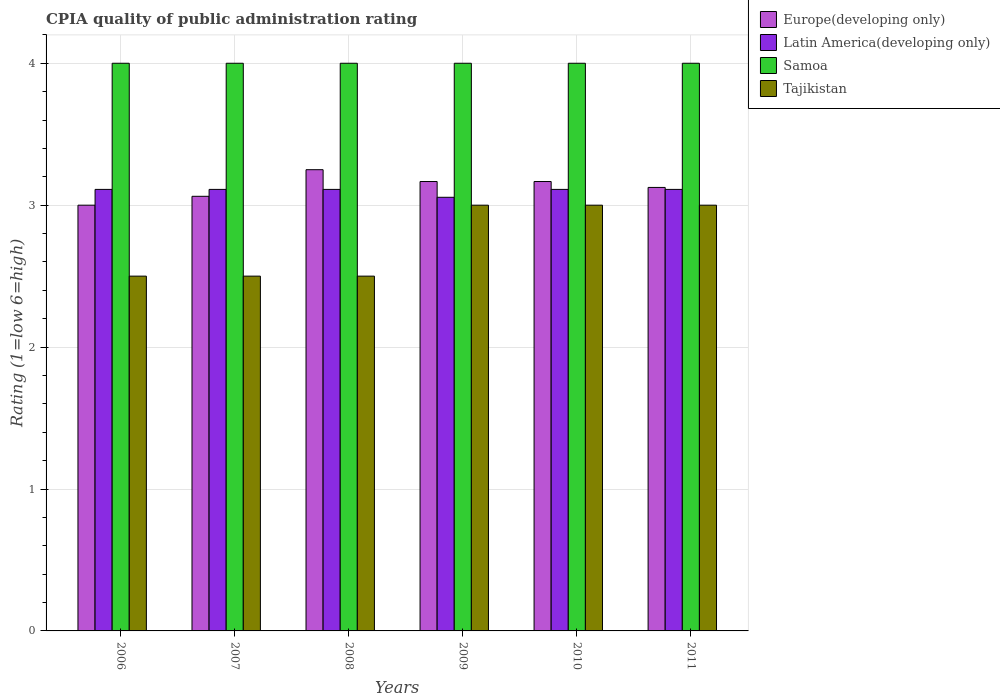How many groups of bars are there?
Make the answer very short. 6. Are the number of bars on each tick of the X-axis equal?
Keep it short and to the point. Yes. How many bars are there on the 2nd tick from the left?
Offer a terse response. 4. How many bars are there on the 4th tick from the right?
Keep it short and to the point. 4. In how many cases, is the number of bars for a given year not equal to the number of legend labels?
Offer a terse response. 0. Across all years, what is the minimum CPIA rating in Latin America(developing only)?
Your answer should be compact. 3.06. In which year was the CPIA rating in Tajikistan maximum?
Your answer should be compact. 2009. What is the difference between the CPIA rating in Europe(developing only) in 2007 and that in 2008?
Offer a terse response. -0.19. What is the difference between the CPIA rating in Tajikistan in 2008 and the CPIA rating in Europe(developing only) in 2010?
Your response must be concise. -0.67. What is the average CPIA rating in Latin America(developing only) per year?
Provide a succinct answer. 3.1. In the year 2007, what is the difference between the CPIA rating in Samoa and CPIA rating in Tajikistan?
Keep it short and to the point. 1.5. In how many years, is the CPIA rating in Samoa greater than 3.2?
Make the answer very short. 6. What is the ratio of the CPIA rating in Europe(developing only) in 2007 to that in 2011?
Your answer should be very brief. 0.98. What is the difference between the highest and the lowest CPIA rating in Latin America(developing only)?
Provide a succinct answer. 0.06. In how many years, is the CPIA rating in Europe(developing only) greater than the average CPIA rating in Europe(developing only) taken over all years?
Offer a terse response. 3. Is the sum of the CPIA rating in Samoa in 2009 and 2011 greater than the maximum CPIA rating in Latin America(developing only) across all years?
Your answer should be very brief. Yes. What does the 1st bar from the left in 2006 represents?
Your answer should be very brief. Europe(developing only). What does the 1st bar from the right in 2008 represents?
Your response must be concise. Tajikistan. Are all the bars in the graph horizontal?
Your response must be concise. No. How many years are there in the graph?
Your response must be concise. 6. Does the graph contain grids?
Provide a succinct answer. Yes. Where does the legend appear in the graph?
Make the answer very short. Top right. How many legend labels are there?
Your answer should be very brief. 4. How are the legend labels stacked?
Your response must be concise. Vertical. What is the title of the graph?
Your answer should be compact. CPIA quality of public administration rating. Does "Algeria" appear as one of the legend labels in the graph?
Keep it short and to the point. No. What is the label or title of the X-axis?
Give a very brief answer. Years. What is the Rating (1=low 6=high) in Latin America(developing only) in 2006?
Your answer should be very brief. 3.11. What is the Rating (1=low 6=high) of Europe(developing only) in 2007?
Provide a short and direct response. 3.06. What is the Rating (1=low 6=high) in Latin America(developing only) in 2007?
Offer a terse response. 3.11. What is the Rating (1=low 6=high) in Tajikistan in 2007?
Your response must be concise. 2.5. What is the Rating (1=low 6=high) in Latin America(developing only) in 2008?
Give a very brief answer. 3.11. What is the Rating (1=low 6=high) of Europe(developing only) in 2009?
Provide a succinct answer. 3.17. What is the Rating (1=low 6=high) of Latin America(developing only) in 2009?
Offer a terse response. 3.06. What is the Rating (1=low 6=high) of Samoa in 2009?
Give a very brief answer. 4. What is the Rating (1=low 6=high) of Tajikistan in 2009?
Provide a succinct answer. 3. What is the Rating (1=low 6=high) in Europe(developing only) in 2010?
Offer a very short reply. 3.17. What is the Rating (1=low 6=high) in Latin America(developing only) in 2010?
Provide a short and direct response. 3.11. What is the Rating (1=low 6=high) of Samoa in 2010?
Your answer should be very brief. 4. What is the Rating (1=low 6=high) of Tajikistan in 2010?
Keep it short and to the point. 3. What is the Rating (1=low 6=high) in Europe(developing only) in 2011?
Provide a short and direct response. 3.12. What is the Rating (1=low 6=high) in Latin America(developing only) in 2011?
Your answer should be very brief. 3.11. Across all years, what is the maximum Rating (1=low 6=high) of Europe(developing only)?
Your response must be concise. 3.25. Across all years, what is the maximum Rating (1=low 6=high) of Latin America(developing only)?
Your answer should be very brief. 3.11. Across all years, what is the maximum Rating (1=low 6=high) of Samoa?
Your answer should be compact. 4. Across all years, what is the maximum Rating (1=low 6=high) of Tajikistan?
Your answer should be compact. 3. Across all years, what is the minimum Rating (1=low 6=high) in Europe(developing only)?
Offer a terse response. 3. Across all years, what is the minimum Rating (1=low 6=high) in Latin America(developing only)?
Your answer should be very brief. 3.06. What is the total Rating (1=low 6=high) of Europe(developing only) in the graph?
Your answer should be compact. 18.77. What is the total Rating (1=low 6=high) of Latin America(developing only) in the graph?
Provide a succinct answer. 18.61. What is the difference between the Rating (1=low 6=high) of Europe(developing only) in 2006 and that in 2007?
Provide a succinct answer. -0.06. What is the difference between the Rating (1=low 6=high) in Latin America(developing only) in 2006 and that in 2007?
Provide a succinct answer. 0. What is the difference between the Rating (1=low 6=high) of Samoa in 2006 and that in 2007?
Your answer should be very brief. 0. What is the difference between the Rating (1=low 6=high) of Tajikistan in 2006 and that in 2007?
Offer a terse response. 0. What is the difference between the Rating (1=low 6=high) in Latin America(developing only) in 2006 and that in 2008?
Give a very brief answer. 0. What is the difference between the Rating (1=low 6=high) of Samoa in 2006 and that in 2008?
Provide a succinct answer. 0. What is the difference between the Rating (1=low 6=high) in Latin America(developing only) in 2006 and that in 2009?
Your response must be concise. 0.06. What is the difference between the Rating (1=low 6=high) in Tajikistan in 2006 and that in 2010?
Provide a succinct answer. -0.5. What is the difference between the Rating (1=low 6=high) of Europe(developing only) in 2006 and that in 2011?
Make the answer very short. -0.12. What is the difference between the Rating (1=low 6=high) of Latin America(developing only) in 2006 and that in 2011?
Provide a succinct answer. 0. What is the difference between the Rating (1=low 6=high) of Samoa in 2006 and that in 2011?
Your answer should be compact. 0. What is the difference between the Rating (1=low 6=high) of Tajikistan in 2006 and that in 2011?
Ensure brevity in your answer.  -0.5. What is the difference between the Rating (1=low 6=high) of Europe(developing only) in 2007 and that in 2008?
Offer a very short reply. -0.19. What is the difference between the Rating (1=low 6=high) in Latin America(developing only) in 2007 and that in 2008?
Keep it short and to the point. 0. What is the difference between the Rating (1=low 6=high) in Samoa in 2007 and that in 2008?
Your answer should be compact. 0. What is the difference between the Rating (1=low 6=high) in Europe(developing only) in 2007 and that in 2009?
Offer a terse response. -0.1. What is the difference between the Rating (1=low 6=high) of Latin America(developing only) in 2007 and that in 2009?
Your response must be concise. 0.06. What is the difference between the Rating (1=low 6=high) of Tajikistan in 2007 and that in 2009?
Give a very brief answer. -0.5. What is the difference between the Rating (1=low 6=high) in Europe(developing only) in 2007 and that in 2010?
Keep it short and to the point. -0.1. What is the difference between the Rating (1=low 6=high) in Latin America(developing only) in 2007 and that in 2010?
Give a very brief answer. 0. What is the difference between the Rating (1=low 6=high) in Europe(developing only) in 2007 and that in 2011?
Your answer should be very brief. -0.06. What is the difference between the Rating (1=low 6=high) in Latin America(developing only) in 2007 and that in 2011?
Offer a very short reply. 0. What is the difference between the Rating (1=low 6=high) in Samoa in 2007 and that in 2011?
Provide a succinct answer. 0. What is the difference between the Rating (1=low 6=high) in Europe(developing only) in 2008 and that in 2009?
Offer a very short reply. 0.08. What is the difference between the Rating (1=low 6=high) in Latin America(developing only) in 2008 and that in 2009?
Keep it short and to the point. 0.06. What is the difference between the Rating (1=low 6=high) of Samoa in 2008 and that in 2009?
Your answer should be compact. 0. What is the difference between the Rating (1=low 6=high) of Tajikistan in 2008 and that in 2009?
Provide a succinct answer. -0.5. What is the difference between the Rating (1=low 6=high) of Europe(developing only) in 2008 and that in 2010?
Offer a very short reply. 0.08. What is the difference between the Rating (1=low 6=high) in Latin America(developing only) in 2008 and that in 2010?
Keep it short and to the point. 0. What is the difference between the Rating (1=low 6=high) in Samoa in 2008 and that in 2010?
Offer a very short reply. 0. What is the difference between the Rating (1=low 6=high) of Tajikistan in 2008 and that in 2010?
Your answer should be very brief. -0.5. What is the difference between the Rating (1=low 6=high) in Europe(developing only) in 2008 and that in 2011?
Your response must be concise. 0.12. What is the difference between the Rating (1=low 6=high) of Samoa in 2008 and that in 2011?
Provide a short and direct response. 0. What is the difference between the Rating (1=low 6=high) in Tajikistan in 2008 and that in 2011?
Provide a short and direct response. -0.5. What is the difference between the Rating (1=low 6=high) in Latin America(developing only) in 2009 and that in 2010?
Your response must be concise. -0.06. What is the difference between the Rating (1=low 6=high) in Samoa in 2009 and that in 2010?
Ensure brevity in your answer.  0. What is the difference between the Rating (1=low 6=high) of Europe(developing only) in 2009 and that in 2011?
Your answer should be compact. 0.04. What is the difference between the Rating (1=low 6=high) of Latin America(developing only) in 2009 and that in 2011?
Your answer should be compact. -0.06. What is the difference between the Rating (1=low 6=high) of Samoa in 2009 and that in 2011?
Keep it short and to the point. 0. What is the difference between the Rating (1=low 6=high) in Europe(developing only) in 2010 and that in 2011?
Your answer should be compact. 0.04. What is the difference between the Rating (1=low 6=high) in Latin America(developing only) in 2010 and that in 2011?
Ensure brevity in your answer.  0. What is the difference between the Rating (1=low 6=high) of Samoa in 2010 and that in 2011?
Ensure brevity in your answer.  0. What is the difference between the Rating (1=low 6=high) of Europe(developing only) in 2006 and the Rating (1=low 6=high) of Latin America(developing only) in 2007?
Ensure brevity in your answer.  -0.11. What is the difference between the Rating (1=low 6=high) in Europe(developing only) in 2006 and the Rating (1=low 6=high) in Samoa in 2007?
Provide a succinct answer. -1. What is the difference between the Rating (1=low 6=high) in Latin America(developing only) in 2006 and the Rating (1=low 6=high) in Samoa in 2007?
Offer a very short reply. -0.89. What is the difference between the Rating (1=low 6=high) in Latin America(developing only) in 2006 and the Rating (1=low 6=high) in Tajikistan in 2007?
Your response must be concise. 0.61. What is the difference between the Rating (1=low 6=high) in Samoa in 2006 and the Rating (1=low 6=high) in Tajikistan in 2007?
Your answer should be compact. 1.5. What is the difference between the Rating (1=low 6=high) in Europe(developing only) in 2006 and the Rating (1=low 6=high) in Latin America(developing only) in 2008?
Your answer should be very brief. -0.11. What is the difference between the Rating (1=low 6=high) in Europe(developing only) in 2006 and the Rating (1=low 6=high) in Samoa in 2008?
Your response must be concise. -1. What is the difference between the Rating (1=low 6=high) in Europe(developing only) in 2006 and the Rating (1=low 6=high) in Tajikistan in 2008?
Your answer should be very brief. 0.5. What is the difference between the Rating (1=low 6=high) of Latin America(developing only) in 2006 and the Rating (1=low 6=high) of Samoa in 2008?
Your answer should be very brief. -0.89. What is the difference between the Rating (1=low 6=high) of Latin America(developing only) in 2006 and the Rating (1=low 6=high) of Tajikistan in 2008?
Keep it short and to the point. 0.61. What is the difference between the Rating (1=low 6=high) of Europe(developing only) in 2006 and the Rating (1=low 6=high) of Latin America(developing only) in 2009?
Give a very brief answer. -0.06. What is the difference between the Rating (1=low 6=high) in Europe(developing only) in 2006 and the Rating (1=low 6=high) in Samoa in 2009?
Offer a very short reply. -1. What is the difference between the Rating (1=low 6=high) in Latin America(developing only) in 2006 and the Rating (1=low 6=high) in Samoa in 2009?
Your answer should be very brief. -0.89. What is the difference between the Rating (1=low 6=high) of Latin America(developing only) in 2006 and the Rating (1=low 6=high) of Tajikistan in 2009?
Your response must be concise. 0.11. What is the difference between the Rating (1=low 6=high) of Samoa in 2006 and the Rating (1=low 6=high) of Tajikistan in 2009?
Ensure brevity in your answer.  1. What is the difference between the Rating (1=low 6=high) in Europe(developing only) in 2006 and the Rating (1=low 6=high) in Latin America(developing only) in 2010?
Your answer should be very brief. -0.11. What is the difference between the Rating (1=low 6=high) in Europe(developing only) in 2006 and the Rating (1=low 6=high) in Samoa in 2010?
Provide a short and direct response. -1. What is the difference between the Rating (1=low 6=high) of Latin America(developing only) in 2006 and the Rating (1=low 6=high) of Samoa in 2010?
Give a very brief answer. -0.89. What is the difference between the Rating (1=low 6=high) of Latin America(developing only) in 2006 and the Rating (1=low 6=high) of Tajikistan in 2010?
Provide a succinct answer. 0.11. What is the difference between the Rating (1=low 6=high) of Samoa in 2006 and the Rating (1=low 6=high) of Tajikistan in 2010?
Ensure brevity in your answer.  1. What is the difference between the Rating (1=low 6=high) of Europe(developing only) in 2006 and the Rating (1=low 6=high) of Latin America(developing only) in 2011?
Give a very brief answer. -0.11. What is the difference between the Rating (1=low 6=high) in Europe(developing only) in 2006 and the Rating (1=low 6=high) in Samoa in 2011?
Offer a very short reply. -1. What is the difference between the Rating (1=low 6=high) in Latin America(developing only) in 2006 and the Rating (1=low 6=high) in Samoa in 2011?
Ensure brevity in your answer.  -0.89. What is the difference between the Rating (1=low 6=high) of Samoa in 2006 and the Rating (1=low 6=high) of Tajikistan in 2011?
Offer a terse response. 1. What is the difference between the Rating (1=low 6=high) of Europe(developing only) in 2007 and the Rating (1=low 6=high) of Latin America(developing only) in 2008?
Give a very brief answer. -0.05. What is the difference between the Rating (1=low 6=high) of Europe(developing only) in 2007 and the Rating (1=low 6=high) of Samoa in 2008?
Offer a terse response. -0.94. What is the difference between the Rating (1=low 6=high) in Europe(developing only) in 2007 and the Rating (1=low 6=high) in Tajikistan in 2008?
Make the answer very short. 0.56. What is the difference between the Rating (1=low 6=high) in Latin America(developing only) in 2007 and the Rating (1=low 6=high) in Samoa in 2008?
Offer a very short reply. -0.89. What is the difference between the Rating (1=low 6=high) of Latin America(developing only) in 2007 and the Rating (1=low 6=high) of Tajikistan in 2008?
Provide a short and direct response. 0.61. What is the difference between the Rating (1=low 6=high) in Samoa in 2007 and the Rating (1=low 6=high) in Tajikistan in 2008?
Provide a succinct answer. 1.5. What is the difference between the Rating (1=low 6=high) in Europe(developing only) in 2007 and the Rating (1=low 6=high) in Latin America(developing only) in 2009?
Offer a very short reply. 0.01. What is the difference between the Rating (1=low 6=high) of Europe(developing only) in 2007 and the Rating (1=low 6=high) of Samoa in 2009?
Offer a terse response. -0.94. What is the difference between the Rating (1=low 6=high) in Europe(developing only) in 2007 and the Rating (1=low 6=high) in Tajikistan in 2009?
Provide a short and direct response. 0.06. What is the difference between the Rating (1=low 6=high) in Latin America(developing only) in 2007 and the Rating (1=low 6=high) in Samoa in 2009?
Offer a very short reply. -0.89. What is the difference between the Rating (1=low 6=high) of Samoa in 2007 and the Rating (1=low 6=high) of Tajikistan in 2009?
Keep it short and to the point. 1. What is the difference between the Rating (1=low 6=high) in Europe(developing only) in 2007 and the Rating (1=low 6=high) in Latin America(developing only) in 2010?
Provide a short and direct response. -0.05. What is the difference between the Rating (1=low 6=high) in Europe(developing only) in 2007 and the Rating (1=low 6=high) in Samoa in 2010?
Give a very brief answer. -0.94. What is the difference between the Rating (1=low 6=high) in Europe(developing only) in 2007 and the Rating (1=low 6=high) in Tajikistan in 2010?
Provide a short and direct response. 0.06. What is the difference between the Rating (1=low 6=high) of Latin America(developing only) in 2007 and the Rating (1=low 6=high) of Samoa in 2010?
Make the answer very short. -0.89. What is the difference between the Rating (1=low 6=high) of Latin America(developing only) in 2007 and the Rating (1=low 6=high) of Tajikistan in 2010?
Ensure brevity in your answer.  0.11. What is the difference between the Rating (1=low 6=high) of Samoa in 2007 and the Rating (1=low 6=high) of Tajikistan in 2010?
Make the answer very short. 1. What is the difference between the Rating (1=low 6=high) in Europe(developing only) in 2007 and the Rating (1=low 6=high) in Latin America(developing only) in 2011?
Provide a short and direct response. -0.05. What is the difference between the Rating (1=low 6=high) in Europe(developing only) in 2007 and the Rating (1=low 6=high) in Samoa in 2011?
Give a very brief answer. -0.94. What is the difference between the Rating (1=low 6=high) of Europe(developing only) in 2007 and the Rating (1=low 6=high) of Tajikistan in 2011?
Offer a terse response. 0.06. What is the difference between the Rating (1=low 6=high) of Latin America(developing only) in 2007 and the Rating (1=low 6=high) of Samoa in 2011?
Offer a very short reply. -0.89. What is the difference between the Rating (1=low 6=high) of Latin America(developing only) in 2007 and the Rating (1=low 6=high) of Tajikistan in 2011?
Keep it short and to the point. 0.11. What is the difference between the Rating (1=low 6=high) in Samoa in 2007 and the Rating (1=low 6=high) in Tajikistan in 2011?
Your response must be concise. 1. What is the difference between the Rating (1=low 6=high) of Europe(developing only) in 2008 and the Rating (1=low 6=high) of Latin America(developing only) in 2009?
Offer a terse response. 0.19. What is the difference between the Rating (1=low 6=high) in Europe(developing only) in 2008 and the Rating (1=low 6=high) in Samoa in 2009?
Offer a terse response. -0.75. What is the difference between the Rating (1=low 6=high) in Europe(developing only) in 2008 and the Rating (1=low 6=high) in Tajikistan in 2009?
Your answer should be very brief. 0.25. What is the difference between the Rating (1=low 6=high) of Latin America(developing only) in 2008 and the Rating (1=low 6=high) of Samoa in 2009?
Make the answer very short. -0.89. What is the difference between the Rating (1=low 6=high) in Samoa in 2008 and the Rating (1=low 6=high) in Tajikistan in 2009?
Offer a terse response. 1. What is the difference between the Rating (1=low 6=high) of Europe(developing only) in 2008 and the Rating (1=low 6=high) of Latin America(developing only) in 2010?
Keep it short and to the point. 0.14. What is the difference between the Rating (1=low 6=high) in Europe(developing only) in 2008 and the Rating (1=low 6=high) in Samoa in 2010?
Provide a short and direct response. -0.75. What is the difference between the Rating (1=low 6=high) in Latin America(developing only) in 2008 and the Rating (1=low 6=high) in Samoa in 2010?
Make the answer very short. -0.89. What is the difference between the Rating (1=low 6=high) in Europe(developing only) in 2008 and the Rating (1=low 6=high) in Latin America(developing only) in 2011?
Provide a succinct answer. 0.14. What is the difference between the Rating (1=low 6=high) in Europe(developing only) in 2008 and the Rating (1=low 6=high) in Samoa in 2011?
Give a very brief answer. -0.75. What is the difference between the Rating (1=low 6=high) of Latin America(developing only) in 2008 and the Rating (1=low 6=high) of Samoa in 2011?
Give a very brief answer. -0.89. What is the difference between the Rating (1=low 6=high) in Latin America(developing only) in 2008 and the Rating (1=low 6=high) in Tajikistan in 2011?
Offer a terse response. 0.11. What is the difference between the Rating (1=low 6=high) in Europe(developing only) in 2009 and the Rating (1=low 6=high) in Latin America(developing only) in 2010?
Keep it short and to the point. 0.06. What is the difference between the Rating (1=low 6=high) of Europe(developing only) in 2009 and the Rating (1=low 6=high) of Samoa in 2010?
Your answer should be very brief. -0.83. What is the difference between the Rating (1=low 6=high) in Europe(developing only) in 2009 and the Rating (1=low 6=high) in Tajikistan in 2010?
Make the answer very short. 0.17. What is the difference between the Rating (1=low 6=high) in Latin America(developing only) in 2009 and the Rating (1=low 6=high) in Samoa in 2010?
Make the answer very short. -0.94. What is the difference between the Rating (1=low 6=high) in Latin America(developing only) in 2009 and the Rating (1=low 6=high) in Tajikistan in 2010?
Give a very brief answer. 0.06. What is the difference between the Rating (1=low 6=high) of Europe(developing only) in 2009 and the Rating (1=low 6=high) of Latin America(developing only) in 2011?
Offer a terse response. 0.06. What is the difference between the Rating (1=low 6=high) of Europe(developing only) in 2009 and the Rating (1=low 6=high) of Samoa in 2011?
Provide a succinct answer. -0.83. What is the difference between the Rating (1=low 6=high) of Europe(developing only) in 2009 and the Rating (1=low 6=high) of Tajikistan in 2011?
Keep it short and to the point. 0.17. What is the difference between the Rating (1=low 6=high) in Latin America(developing only) in 2009 and the Rating (1=low 6=high) in Samoa in 2011?
Make the answer very short. -0.94. What is the difference between the Rating (1=low 6=high) of Latin America(developing only) in 2009 and the Rating (1=low 6=high) of Tajikistan in 2011?
Provide a succinct answer. 0.06. What is the difference between the Rating (1=low 6=high) of Samoa in 2009 and the Rating (1=low 6=high) of Tajikistan in 2011?
Your answer should be very brief. 1. What is the difference between the Rating (1=low 6=high) in Europe(developing only) in 2010 and the Rating (1=low 6=high) in Latin America(developing only) in 2011?
Ensure brevity in your answer.  0.06. What is the difference between the Rating (1=low 6=high) of Europe(developing only) in 2010 and the Rating (1=low 6=high) of Samoa in 2011?
Your answer should be very brief. -0.83. What is the difference between the Rating (1=low 6=high) in Latin America(developing only) in 2010 and the Rating (1=low 6=high) in Samoa in 2011?
Your answer should be very brief. -0.89. What is the difference between the Rating (1=low 6=high) in Samoa in 2010 and the Rating (1=low 6=high) in Tajikistan in 2011?
Give a very brief answer. 1. What is the average Rating (1=low 6=high) of Europe(developing only) per year?
Offer a terse response. 3.13. What is the average Rating (1=low 6=high) in Latin America(developing only) per year?
Keep it short and to the point. 3.1. What is the average Rating (1=low 6=high) of Samoa per year?
Provide a short and direct response. 4. What is the average Rating (1=low 6=high) of Tajikistan per year?
Keep it short and to the point. 2.75. In the year 2006, what is the difference between the Rating (1=low 6=high) in Europe(developing only) and Rating (1=low 6=high) in Latin America(developing only)?
Offer a terse response. -0.11. In the year 2006, what is the difference between the Rating (1=low 6=high) of Latin America(developing only) and Rating (1=low 6=high) of Samoa?
Offer a very short reply. -0.89. In the year 2006, what is the difference between the Rating (1=low 6=high) in Latin America(developing only) and Rating (1=low 6=high) in Tajikistan?
Offer a terse response. 0.61. In the year 2007, what is the difference between the Rating (1=low 6=high) in Europe(developing only) and Rating (1=low 6=high) in Latin America(developing only)?
Give a very brief answer. -0.05. In the year 2007, what is the difference between the Rating (1=low 6=high) in Europe(developing only) and Rating (1=low 6=high) in Samoa?
Your answer should be very brief. -0.94. In the year 2007, what is the difference between the Rating (1=low 6=high) in Europe(developing only) and Rating (1=low 6=high) in Tajikistan?
Ensure brevity in your answer.  0.56. In the year 2007, what is the difference between the Rating (1=low 6=high) of Latin America(developing only) and Rating (1=low 6=high) of Samoa?
Your response must be concise. -0.89. In the year 2007, what is the difference between the Rating (1=low 6=high) in Latin America(developing only) and Rating (1=low 6=high) in Tajikistan?
Your response must be concise. 0.61. In the year 2008, what is the difference between the Rating (1=low 6=high) in Europe(developing only) and Rating (1=low 6=high) in Latin America(developing only)?
Provide a succinct answer. 0.14. In the year 2008, what is the difference between the Rating (1=low 6=high) of Europe(developing only) and Rating (1=low 6=high) of Samoa?
Give a very brief answer. -0.75. In the year 2008, what is the difference between the Rating (1=low 6=high) in Latin America(developing only) and Rating (1=low 6=high) in Samoa?
Provide a succinct answer. -0.89. In the year 2008, what is the difference between the Rating (1=low 6=high) in Latin America(developing only) and Rating (1=low 6=high) in Tajikistan?
Offer a terse response. 0.61. In the year 2008, what is the difference between the Rating (1=low 6=high) in Samoa and Rating (1=low 6=high) in Tajikistan?
Provide a short and direct response. 1.5. In the year 2009, what is the difference between the Rating (1=low 6=high) of Europe(developing only) and Rating (1=low 6=high) of Latin America(developing only)?
Offer a terse response. 0.11. In the year 2009, what is the difference between the Rating (1=low 6=high) in Europe(developing only) and Rating (1=low 6=high) in Tajikistan?
Make the answer very short. 0.17. In the year 2009, what is the difference between the Rating (1=low 6=high) in Latin America(developing only) and Rating (1=low 6=high) in Samoa?
Ensure brevity in your answer.  -0.94. In the year 2009, what is the difference between the Rating (1=low 6=high) in Latin America(developing only) and Rating (1=low 6=high) in Tajikistan?
Your response must be concise. 0.06. In the year 2010, what is the difference between the Rating (1=low 6=high) of Europe(developing only) and Rating (1=low 6=high) of Latin America(developing only)?
Provide a short and direct response. 0.06. In the year 2010, what is the difference between the Rating (1=low 6=high) in Europe(developing only) and Rating (1=low 6=high) in Samoa?
Offer a terse response. -0.83. In the year 2010, what is the difference between the Rating (1=low 6=high) in Latin America(developing only) and Rating (1=low 6=high) in Samoa?
Your response must be concise. -0.89. In the year 2010, what is the difference between the Rating (1=low 6=high) in Latin America(developing only) and Rating (1=low 6=high) in Tajikistan?
Offer a terse response. 0.11. In the year 2010, what is the difference between the Rating (1=low 6=high) in Samoa and Rating (1=low 6=high) in Tajikistan?
Your answer should be very brief. 1. In the year 2011, what is the difference between the Rating (1=low 6=high) of Europe(developing only) and Rating (1=low 6=high) of Latin America(developing only)?
Your answer should be compact. 0.01. In the year 2011, what is the difference between the Rating (1=low 6=high) of Europe(developing only) and Rating (1=low 6=high) of Samoa?
Keep it short and to the point. -0.88. In the year 2011, what is the difference between the Rating (1=low 6=high) in Latin America(developing only) and Rating (1=low 6=high) in Samoa?
Make the answer very short. -0.89. What is the ratio of the Rating (1=low 6=high) of Europe(developing only) in 2006 to that in 2007?
Offer a terse response. 0.98. What is the ratio of the Rating (1=low 6=high) in Latin America(developing only) in 2006 to that in 2008?
Ensure brevity in your answer.  1. What is the ratio of the Rating (1=low 6=high) of Samoa in 2006 to that in 2008?
Ensure brevity in your answer.  1. What is the ratio of the Rating (1=low 6=high) in Tajikistan in 2006 to that in 2008?
Your answer should be very brief. 1. What is the ratio of the Rating (1=low 6=high) of Europe(developing only) in 2006 to that in 2009?
Keep it short and to the point. 0.95. What is the ratio of the Rating (1=low 6=high) of Latin America(developing only) in 2006 to that in 2009?
Your answer should be compact. 1.02. What is the ratio of the Rating (1=low 6=high) in Samoa in 2006 to that in 2009?
Your answer should be compact. 1. What is the ratio of the Rating (1=low 6=high) in Tajikistan in 2006 to that in 2009?
Provide a short and direct response. 0.83. What is the ratio of the Rating (1=low 6=high) of Europe(developing only) in 2006 to that in 2010?
Your answer should be very brief. 0.95. What is the ratio of the Rating (1=low 6=high) in Latin America(developing only) in 2006 to that in 2011?
Ensure brevity in your answer.  1. What is the ratio of the Rating (1=low 6=high) in Samoa in 2006 to that in 2011?
Offer a very short reply. 1. What is the ratio of the Rating (1=low 6=high) of Tajikistan in 2006 to that in 2011?
Keep it short and to the point. 0.83. What is the ratio of the Rating (1=low 6=high) in Europe(developing only) in 2007 to that in 2008?
Ensure brevity in your answer.  0.94. What is the ratio of the Rating (1=low 6=high) of Latin America(developing only) in 2007 to that in 2008?
Make the answer very short. 1. What is the ratio of the Rating (1=low 6=high) in Tajikistan in 2007 to that in 2008?
Your response must be concise. 1. What is the ratio of the Rating (1=low 6=high) of Europe(developing only) in 2007 to that in 2009?
Offer a very short reply. 0.97. What is the ratio of the Rating (1=low 6=high) of Latin America(developing only) in 2007 to that in 2009?
Ensure brevity in your answer.  1.02. What is the ratio of the Rating (1=low 6=high) of Samoa in 2007 to that in 2009?
Your response must be concise. 1. What is the ratio of the Rating (1=low 6=high) in Europe(developing only) in 2007 to that in 2010?
Your answer should be very brief. 0.97. What is the ratio of the Rating (1=low 6=high) in Samoa in 2007 to that in 2010?
Your response must be concise. 1. What is the ratio of the Rating (1=low 6=high) of Latin America(developing only) in 2007 to that in 2011?
Offer a very short reply. 1. What is the ratio of the Rating (1=low 6=high) in Samoa in 2007 to that in 2011?
Offer a terse response. 1. What is the ratio of the Rating (1=low 6=high) in Europe(developing only) in 2008 to that in 2009?
Your answer should be very brief. 1.03. What is the ratio of the Rating (1=low 6=high) of Latin America(developing only) in 2008 to that in 2009?
Offer a terse response. 1.02. What is the ratio of the Rating (1=low 6=high) in Samoa in 2008 to that in 2009?
Give a very brief answer. 1. What is the ratio of the Rating (1=low 6=high) of Tajikistan in 2008 to that in 2009?
Provide a succinct answer. 0.83. What is the ratio of the Rating (1=low 6=high) in Europe(developing only) in 2008 to that in 2010?
Make the answer very short. 1.03. What is the ratio of the Rating (1=low 6=high) of Tajikistan in 2008 to that in 2010?
Provide a succinct answer. 0.83. What is the ratio of the Rating (1=low 6=high) of Europe(developing only) in 2008 to that in 2011?
Make the answer very short. 1.04. What is the ratio of the Rating (1=low 6=high) of Latin America(developing only) in 2008 to that in 2011?
Make the answer very short. 1. What is the ratio of the Rating (1=low 6=high) of Samoa in 2008 to that in 2011?
Keep it short and to the point. 1. What is the ratio of the Rating (1=low 6=high) in Latin America(developing only) in 2009 to that in 2010?
Give a very brief answer. 0.98. What is the ratio of the Rating (1=low 6=high) of Samoa in 2009 to that in 2010?
Your answer should be very brief. 1. What is the ratio of the Rating (1=low 6=high) in Tajikistan in 2009 to that in 2010?
Provide a short and direct response. 1. What is the ratio of the Rating (1=low 6=high) of Europe(developing only) in 2009 to that in 2011?
Your answer should be very brief. 1.01. What is the ratio of the Rating (1=low 6=high) of Latin America(developing only) in 2009 to that in 2011?
Give a very brief answer. 0.98. What is the ratio of the Rating (1=low 6=high) in Samoa in 2009 to that in 2011?
Your answer should be very brief. 1. What is the ratio of the Rating (1=low 6=high) of Tajikistan in 2009 to that in 2011?
Your answer should be compact. 1. What is the ratio of the Rating (1=low 6=high) in Europe(developing only) in 2010 to that in 2011?
Provide a short and direct response. 1.01. What is the ratio of the Rating (1=low 6=high) of Samoa in 2010 to that in 2011?
Give a very brief answer. 1. What is the difference between the highest and the second highest Rating (1=low 6=high) of Europe(developing only)?
Provide a succinct answer. 0.08. What is the difference between the highest and the second highest Rating (1=low 6=high) of Samoa?
Your answer should be compact. 0. What is the difference between the highest and the second highest Rating (1=low 6=high) in Tajikistan?
Your response must be concise. 0. What is the difference between the highest and the lowest Rating (1=low 6=high) of Latin America(developing only)?
Give a very brief answer. 0.06. 